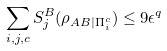Convert formula to latex. <formula><loc_0><loc_0><loc_500><loc_500>\sum _ { i , j , c } S ^ { B } _ { j } ( \rho _ { A B | \Pi _ { i } ^ { c } } ) \leq 9 \epsilon ^ { q }</formula> 